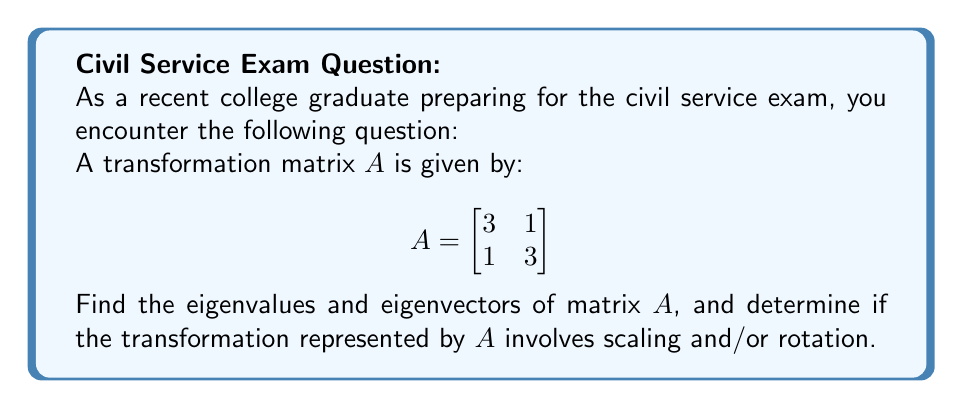What is the answer to this math problem? Step 1: Find the characteristic equation
The characteristic equation is given by $\det(A - \lambda I) = 0$, where $\lambda$ represents the eigenvalues.

$$\det\begin{pmatrix}
3-\lambda & 1 \\
1 & 3-\lambda
\end{pmatrix} = 0$$

$(3-\lambda)(3-\lambda) - 1 = 0$
$(3-\lambda)^2 - 1 = 0$
$9 - 6\lambda + \lambda^2 - 1 = 0$
$\lambda^2 - 6\lambda + 8 = 0$

Step 2: Solve for eigenvalues
Using the quadratic formula, we get:
$\lambda = \frac{6 \pm \sqrt{36 - 32}}{2} = \frac{6 \pm \sqrt{4}}{2} = \frac{6 \pm 2}{2}$

$\lambda_1 = 4$ and $\lambda_2 = 2$

Step 3: Find eigenvectors
For $\lambda_1 = 4$:
$$(A - 4I)\vec{v_1} = \vec{0}$$
$$\begin{pmatrix}
-1 & 1 \\
1 & -1
\end{pmatrix}\begin{pmatrix}
x \\
y
\end{pmatrix} = \begin{pmatrix}
0 \\
0
\end{pmatrix}$$

This gives us: $-x + y = 0$ or $x = y$
An eigenvector for $\lambda_1 = 4$ is $\vec{v_1} = \begin{pmatrix} 1 \\ 1 \end{pmatrix}$

For $\lambda_2 = 2$:
$$(A - 2I)\vec{v_2} = \vec{0}$$
$$\begin{pmatrix}
1 & 1 \\
1 & 1
\end{pmatrix}\begin{pmatrix}
x \\
y
\end{pmatrix} = \begin{pmatrix}
0 \\
0
\end{pmatrix}$$

This gives us: $x + y = 0$ or $x = -y$
An eigenvector for $\lambda_2 = 2$ is $\vec{v_2} = \begin{pmatrix} 1 \\ -1 \end{pmatrix}$

Step 4: Interpret the results
Both eigenvalues are real and positive, indicating that the transformation involves scaling. The eigenvectors are perpendicular to each other, which means there is no rotation involved in the transformation.
Answer: Eigenvalues: $\lambda_1 = 4$, $\lambda_2 = 2$
Eigenvectors: $\vec{v_1} = \begin{pmatrix} 1 \\ 1 \end{pmatrix}$, $\vec{v_2} = \begin{pmatrix} 1 \\ -1 \end{pmatrix}$
The transformation involves scaling only, no rotation. 